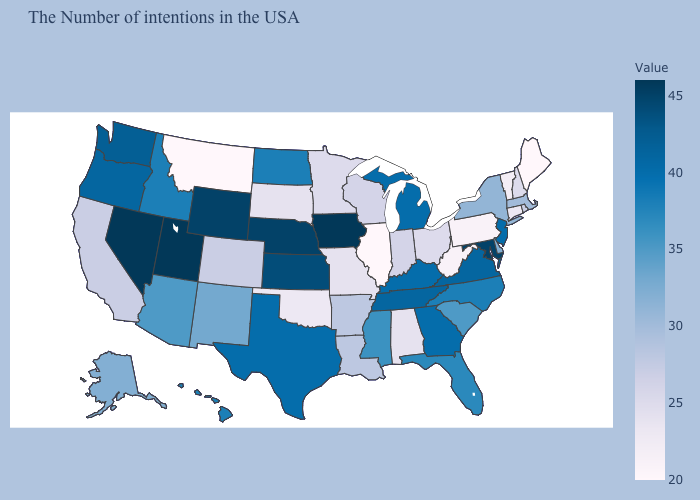Which states have the lowest value in the MidWest?
Short answer required. Illinois. Does Maryland have a lower value than Connecticut?
Give a very brief answer. No. Does the map have missing data?
Write a very short answer. No. 